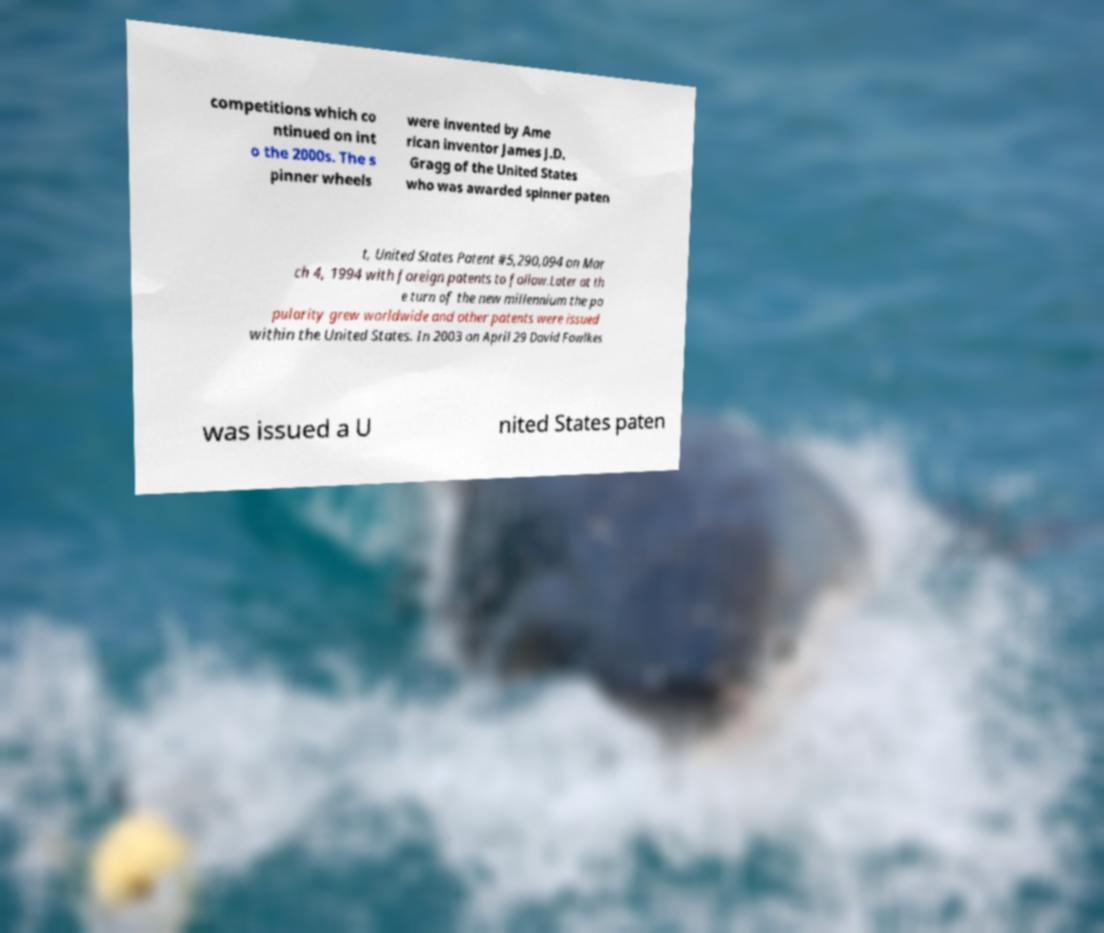Please read and relay the text visible in this image. What does it say? competitions which co ntinued on int o the 2000s. The s pinner wheels were invented by Ame rican inventor James J.D. Gragg of the United States who was awarded spinner paten t, United States Patent #5,290,094 on Mar ch 4, 1994 with foreign patents to follow.Later at th e turn of the new millennium the po pularity grew worldwide and other patents were issued within the United States. In 2003 on April 29 David Fowlkes was issued a U nited States paten 